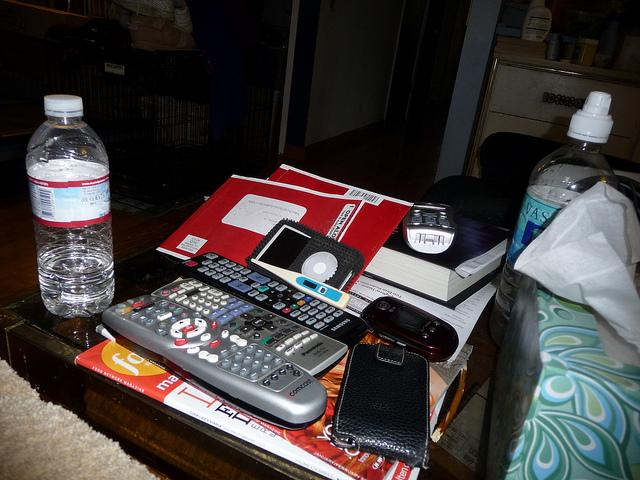The red envelopes on the table indicate that there is what electronic device in the room? Please explain your reasoning. dvd player. These types of envelopes were commonly used with movie discs at one point. 